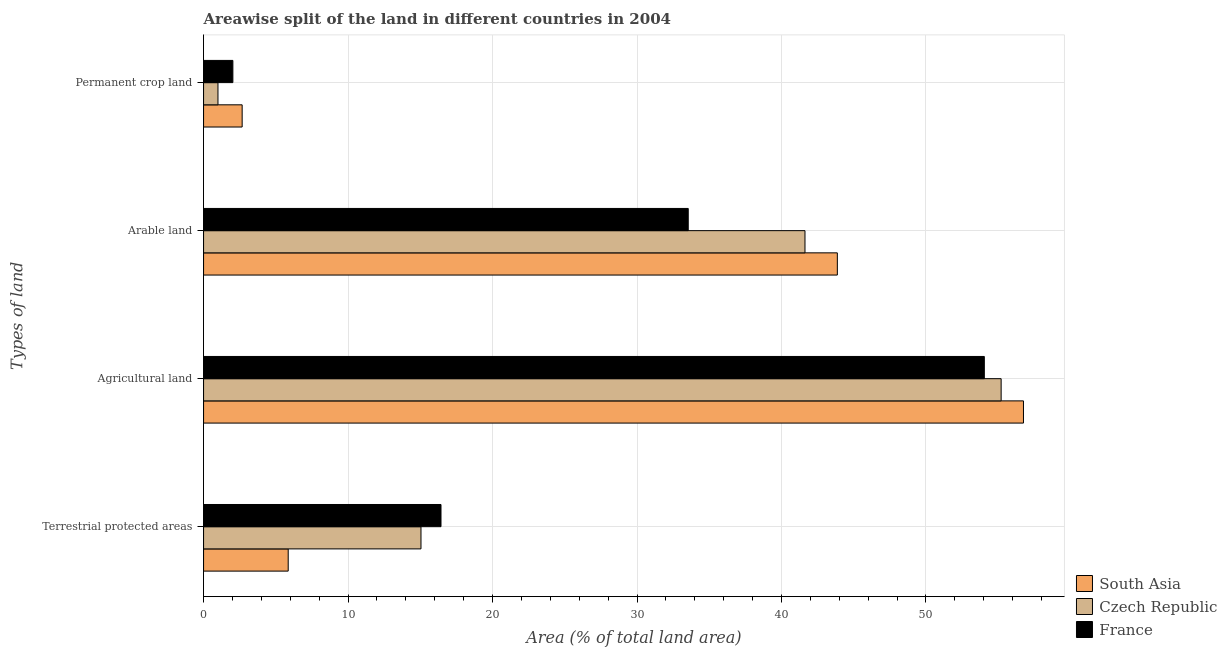How many groups of bars are there?
Keep it short and to the point. 4. Are the number of bars on each tick of the Y-axis equal?
Keep it short and to the point. Yes. What is the label of the 1st group of bars from the top?
Your answer should be compact. Permanent crop land. What is the percentage of area under agricultural land in France?
Your response must be concise. 54.04. Across all countries, what is the maximum percentage of area under permanent crop land?
Ensure brevity in your answer.  2.67. Across all countries, what is the minimum percentage of land under terrestrial protection?
Your answer should be compact. 5.86. In which country was the percentage of area under arable land maximum?
Your answer should be compact. South Asia. In which country was the percentage of area under agricultural land minimum?
Offer a terse response. France. What is the total percentage of area under permanent crop land in the graph?
Offer a very short reply. 5.7. What is the difference between the percentage of area under arable land in Czech Republic and that in South Asia?
Give a very brief answer. -2.24. What is the difference between the percentage of area under permanent crop land in France and the percentage of area under agricultural land in South Asia?
Provide a succinct answer. -54.72. What is the average percentage of land under terrestrial protection per country?
Offer a very short reply. 12.45. What is the difference between the percentage of area under agricultural land and percentage of area under permanent crop land in France?
Your response must be concise. 52.01. In how many countries, is the percentage of area under arable land greater than 2 %?
Offer a very short reply. 3. What is the ratio of the percentage of area under agricultural land in Czech Republic to that in France?
Ensure brevity in your answer.  1.02. Is the percentage of land under terrestrial protection in South Asia less than that in France?
Keep it short and to the point. Yes. What is the difference between the highest and the second highest percentage of area under permanent crop land?
Provide a short and direct response. 0.64. What is the difference between the highest and the lowest percentage of area under agricultural land?
Offer a very short reply. 2.71. Is it the case that in every country, the sum of the percentage of area under permanent crop land and percentage of land under terrestrial protection is greater than the sum of percentage of area under arable land and percentage of area under agricultural land?
Provide a succinct answer. Yes. What does the 2nd bar from the bottom in Arable land represents?
Your answer should be very brief. Czech Republic. Is it the case that in every country, the sum of the percentage of land under terrestrial protection and percentage of area under agricultural land is greater than the percentage of area under arable land?
Ensure brevity in your answer.  Yes. How many bars are there?
Offer a very short reply. 12. Are all the bars in the graph horizontal?
Ensure brevity in your answer.  Yes. What is the difference between two consecutive major ticks on the X-axis?
Provide a succinct answer. 10. Are the values on the major ticks of X-axis written in scientific E-notation?
Your answer should be very brief. No. Does the graph contain any zero values?
Provide a short and direct response. No. Does the graph contain grids?
Ensure brevity in your answer.  Yes. Where does the legend appear in the graph?
Provide a short and direct response. Bottom right. How are the legend labels stacked?
Your answer should be very brief. Vertical. What is the title of the graph?
Provide a short and direct response. Areawise split of the land in different countries in 2004. Does "Belarus" appear as one of the legend labels in the graph?
Keep it short and to the point. No. What is the label or title of the X-axis?
Your answer should be compact. Area (% of total land area). What is the label or title of the Y-axis?
Provide a succinct answer. Types of land. What is the Area (% of total land area) of South Asia in Terrestrial protected areas?
Ensure brevity in your answer.  5.86. What is the Area (% of total land area) in Czech Republic in Terrestrial protected areas?
Your response must be concise. 15.05. What is the Area (% of total land area) of France in Terrestrial protected areas?
Your response must be concise. 16.43. What is the Area (% of total land area) in South Asia in Agricultural land?
Make the answer very short. 56.75. What is the Area (% of total land area) of Czech Republic in Agricultural land?
Your answer should be very brief. 55.2. What is the Area (% of total land area) of France in Agricultural land?
Provide a succinct answer. 54.04. What is the Area (% of total land area) of South Asia in Arable land?
Keep it short and to the point. 43.87. What is the Area (% of total land area) in Czech Republic in Arable land?
Offer a very short reply. 41.63. What is the Area (% of total land area) of France in Arable land?
Give a very brief answer. 33.55. What is the Area (% of total land area) in South Asia in Permanent crop land?
Offer a very short reply. 2.67. What is the Area (% of total land area) of Czech Republic in Permanent crop land?
Your response must be concise. 1. What is the Area (% of total land area) of France in Permanent crop land?
Offer a terse response. 2.03. Across all Types of land, what is the maximum Area (% of total land area) in South Asia?
Ensure brevity in your answer.  56.75. Across all Types of land, what is the maximum Area (% of total land area) of Czech Republic?
Provide a short and direct response. 55.2. Across all Types of land, what is the maximum Area (% of total land area) of France?
Provide a succinct answer. 54.04. Across all Types of land, what is the minimum Area (% of total land area) of South Asia?
Your response must be concise. 2.67. Across all Types of land, what is the minimum Area (% of total land area) of Czech Republic?
Provide a short and direct response. 1. Across all Types of land, what is the minimum Area (% of total land area) of France?
Give a very brief answer. 2.03. What is the total Area (% of total land area) of South Asia in the graph?
Your answer should be very brief. 109.14. What is the total Area (% of total land area) of Czech Republic in the graph?
Your answer should be very brief. 112.87. What is the total Area (% of total land area) of France in the graph?
Provide a succinct answer. 106.05. What is the difference between the Area (% of total land area) in South Asia in Terrestrial protected areas and that in Agricultural land?
Your answer should be compact. -50.89. What is the difference between the Area (% of total land area) of Czech Republic in Terrestrial protected areas and that in Agricultural land?
Offer a very short reply. -40.15. What is the difference between the Area (% of total land area) in France in Terrestrial protected areas and that in Agricultural land?
Give a very brief answer. -37.61. What is the difference between the Area (% of total land area) in South Asia in Terrestrial protected areas and that in Arable land?
Provide a short and direct response. -38.01. What is the difference between the Area (% of total land area) in Czech Republic in Terrestrial protected areas and that in Arable land?
Keep it short and to the point. -26.58. What is the difference between the Area (% of total land area) in France in Terrestrial protected areas and that in Arable land?
Provide a short and direct response. -17.11. What is the difference between the Area (% of total land area) in South Asia in Terrestrial protected areas and that in Permanent crop land?
Your response must be concise. 3.19. What is the difference between the Area (% of total land area) of Czech Republic in Terrestrial protected areas and that in Permanent crop land?
Provide a succinct answer. 14.05. What is the difference between the Area (% of total land area) in France in Terrestrial protected areas and that in Permanent crop land?
Your answer should be very brief. 14.4. What is the difference between the Area (% of total land area) in South Asia in Agricultural land and that in Arable land?
Provide a short and direct response. 12.88. What is the difference between the Area (% of total land area) of Czech Republic in Agricultural land and that in Arable land?
Offer a terse response. 13.58. What is the difference between the Area (% of total land area) of France in Agricultural land and that in Arable land?
Give a very brief answer. 20.49. What is the difference between the Area (% of total land area) in South Asia in Agricultural land and that in Permanent crop land?
Provide a short and direct response. 54.08. What is the difference between the Area (% of total land area) of Czech Republic in Agricultural land and that in Permanent crop land?
Your answer should be compact. 54.21. What is the difference between the Area (% of total land area) in France in Agricultural land and that in Permanent crop land?
Make the answer very short. 52.01. What is the difference between the Area (% of total land area) of South Asia in Arable land and that in Permanent crop land?
Make the answer very short. 41.2. What is the difference between the Area (% of total land area) in Czech Republic in Arable land and that in Permanent crop land?
Make the answer very short. 40.63. What is the difference between the Area (% of total land area) in France in Arable land and that in Permanent crop land?
Make the answer very short. 31.52. What is the difference between the Area (% of total land area) of South Asia in Terrestrial protected areas and the Area (% of total land area) of Czech Republic in Agricultural land?
Your answer should be compact. -49.35. What is the difference between the Area (% of total land area) in South Asia in Terrestrial protected areas and the Area (% of total land area) in France in Agricultural land?
Keep it short and to the point. -48.18. What is the difference between the Area (% of total land area) of Czech Republic in Terrestrial protected areas and the Area (% of total land area) of France in Agricultural land?
Offer a terse response. -38.99. What is the difference between the Area (% of total land area) of South Asia in Terrestrial protected areas and the Area (% of total land area) of Czech Republic in Arable land?
Make the answer very short. -35.77. What is the difference between the Area (% of total land area) of South Asia in Terrestrial protected areas and the Area (% of total land area) of France in Arable land?
Give a very brief answer. -27.69. What is the difference between the Area (% of total land area) of Czech Republic in Terrestrial protected areas and the Area (% of total land area) of France in Arable land?
Keep it short and to the point. -18.5. What is the difference between the Area (% of total land area) in South Asia in Terrestrial protected areas and the Area (% of total land area) in Czech Republic in Permanent crop land?
Your answer should be very brief. 4.86. What is the difference between the Area (% of total land area) of South Asia in Terrestrial protected areas and the Area (% of total land area) of France in Permanent crop land?
Your response must be concise. 3.83. What is the difference between the Area (% of total land area) in Czech Republic in Terrestrial protected areas and the Area (% of total land area) in France in Permanent crop land?
Your answer should be very brief. 13.02. What is the difference between the Area (% of total land area) in South Asia in Agricultural land and the Area (% of total land area) in Czech Republic in Arable land?
Your answer should be compact. 15.12. What is the difference between the Area (% of total land area) of South Asia in Agricultural land and the Area (% of total land area) of France in Arable land?
Provide a short and direct response. 23.2. What is the difference between the Area (% of total land area) in Czech Republic in Agricultural land and the Area (% of total land area) in France in Arable land?
Make the answer very short. 21.66. What is the difference between the Area (% of total land area) of South Asia in Agricultural land and the Area (% of total land area) of Czech Republic in Permanent crop land?
Your response must be concise. 55.75. What is the difference between the Area (% of total land area) in South Asia in Agricultural land and the Area (% of total land area) in France in Permanent crop land?
Give a very brief answer. 54.72. What is the difference between the Area (% of total land area) of Czech Republic in Agricultural land and the Area (% of total land area) of France in Permanent crop land?
Give a very brief answer. 53.17. What is the difference between the Area (% of total land area) in South Asia in Arable land and the Area (% of total land area) in Czech Republic in Permanent crop land?
Offer a very short reply. 42.87. What is the difference between the Area (% of total land area) in South Asia in Arable land and the Area (% of total land area) in France in Permanent crop land?
Offer a very short reply. 41.84. What is the difference between the Area (% of total land area) of Czech Republic in Arable land and the Area (% of total land area) of France in Permanent crop land?
Keep it short and to the point. 39.6. What is the average Area (% of total land area) in South Asia per Types of land?
Your response must be concise. 27.29. What is the average Area (% of total land area) in Czech Republic per Types of land?
Keep it short and to the point. 28.22. What is the average Area (% of total land area) in France per Types of land?
Ensure brevity in your answer.  26.51. What is the difference between the Area (% of total land area) in South Asia and Area (% of total land area) in Czech Republic in Terrestrial protected areas?
Your answer should be very brief. -9.19. What is the difference between the Area (% of total land area) of South Asia and Area (% of total land area) of France in Terrestrial protected areas?
Your answer should be compact. -10.58. What is the difference between the Area (% of total land area) in Czech Republic and Area (% of total land area) in France in Terrestrial protected areas?
Give a very brief answer. -1.38. What is the difference between the Area (% of total land area) of South Asia and Area (% of total land area) of Czech Republic in Agricultural land?
Offer a terse response. 1.54. What is the difference between the Area (% of total land area) of South Asia and Area (% of total land area) of France in Agricultural land?
Make the answer very short. 2.71. What is the difference between the Area (% of total land area) in Czech Republic and Area (% of total land area) in France in Agricultural land?
Your answer should be compact. 1.16. What is the difference between the Area (% of total land area) of South Asia and Area (% of total land area) of Czech Republic in Arable land?
Give a very brief answer. 2.24. What is the difference between the Area (% of total land area) of South Asia and Area (% of total land area) of France in Arable land?
Provide a short and direct response. 10.32. What is the difference between the Area (% of total land area) in Czech Republic and Area (% of total land area) in France in Arable land?
Your answer should be very brief. 8.08. What is the difference between the Area (% of total land area) in South Asia and Area (% of total land area) in Czech Republic in Permanent crop land?
Offer a terse response. 1.67. What is the difference between the Area (% of total land area) in South Asia and Area (% of total land area) in France in Permanent crop land?
Offer a very short reply. 0.64. What is the difference between the Area (% of total land area) of Czech Republic and Area (% of total land area) of France in Permanent crop land?
Keep it short and to the point. -1.03. What is the ratio of the Area (% of total land area) in South Asia in Terrestrial protected areas to that in Agricultural land?
Make the answer very short. 0.1. What is the ratio of the Area (% of total land area) in Czech Republic in Terrestrial protected areas to that in Agricultural land?
Your answer should be very brief. 0.27. What is the ratio of the Area (% of total land area) of France in Terrestrial protected areas to that in Agricultural land?
Your answer should be very brief. 0.3. What is the ratio of the Area (% of total land area) in South Asia in Terrestrial protected areas to that in Arable land?
Offer a terse response. 0.13. What is the ratio of the Area (% of total land area) in Czech Republic in Terrestrial protected areas to that in Arable land?
Ensure brevity in your answer.  0.36. What is the ratio of the Area (% of total land area) in France in Terrestrial protected areas to that in Arable land?
Your response must be concise. 0.49. What is the ratio of the Area (% of total land area) in South Asia in Terrestrial protected areas to that in Permanent crop land?
Give a very brief answer. 2.19. What is the ratio of the Area (% of total land area) in Czech Republic in Terrestrial protected areas to that in Permanent crop land?
Provide a succinct answer. 15.1. What is the ratio of the Area (% of total land area) in France in Terrestrial protected areas to that in Permanent crop land?
Make the answer very short. 8.1. What is the ratio of the Area (% of total land area) of South Asia in Agricultural land to that in Arable land?
Keep it short and to the point. 1.29. What is the ratio of the Area (% of total land area) of Czech Republic in Agricultural land to that in Arable land?
Your answer should be very brief. 1.33. What is the ratio of the Area (% of total land area) of France in Agricultural land to that in Arable land?
Your answer should be very brief. 1.61. What is the ratio of the Area (% of total land area) in South Asia in Agricultural land to that in Permanent crop land?
Your answer should be compact. 21.24. What is the ratio of the Area (% of total land area) of Czech Republic in Agricultural land to that in Permanent crop land?
Provide a short and direct response. 55.39. What is the ratio of the Area (% of total land area) in France in Agricultural land to that in Permanent crop land?
Offer a very short reply. 26.64. What is the ratio of the Area (% of total land area) of South Asia in Arable land to that in Permanent crop land?
Give a very brief answer. 16.42. What is the ratio of the Area (% of total land area) in Czech Republic in Arable land to that in Permanent crop land?
Your answer should be compact. 41.77. What is the ratio of the Area (% of total land area) in France in Arable land to that in Permanent crop land?
Your answer should be compact. 16.54. What is the difference between the highest and the second highest Area (% of total land area) of South Asia?
Provide a short and direct response. 12.88. What is the difference between the highest and the second highest Area (% of total land area) in Czech Republic?
Provide a succinct answer. 13.58. What is the difference between the highest and the second highest Area (% of total land area) of France?
Offer a very short reply. 20.49. What is the difference between the highest and the lowest Area (% of total land area) of South Asia?
Ensure brevity in your answer.  54.08. What is the difference between the highest and the lowest Area (% of total land area) in Czech Republic?
Your answer should be very brief. 54.21. What is the difference between the highest and the lowest Area (% of total land area) of France?
Offer a terse response. 52.01. 